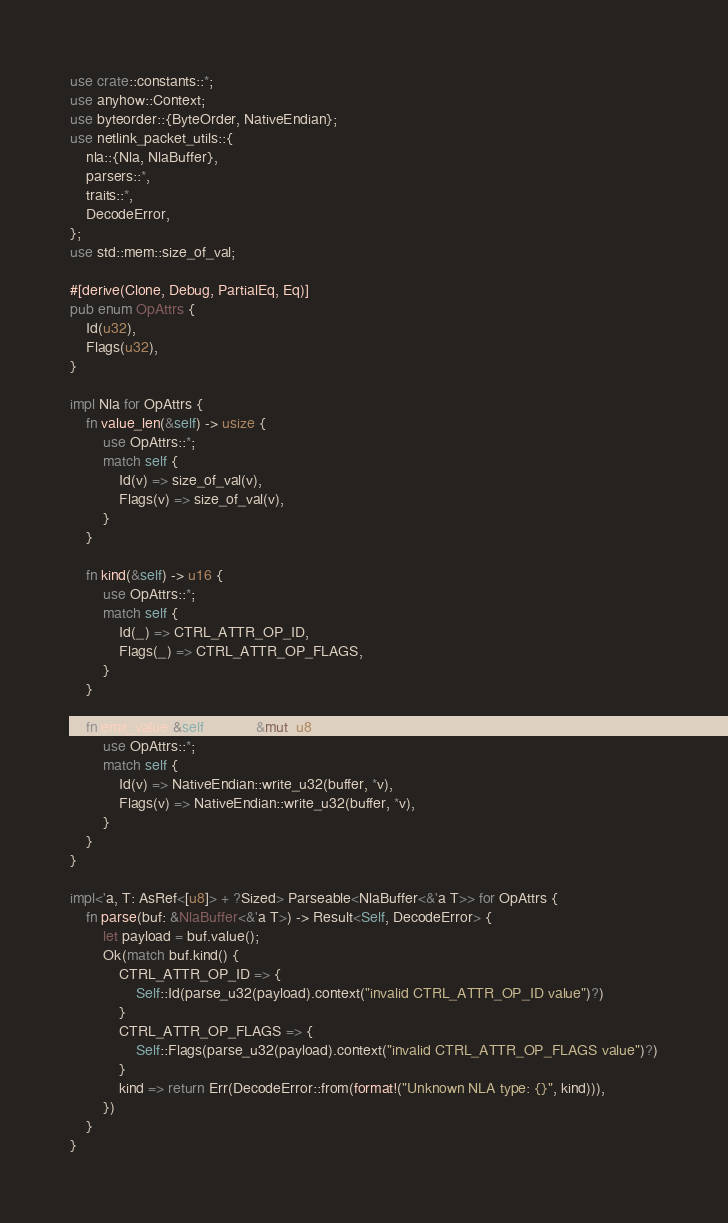Convert code to text. <code><loc_0><loc_0><loc_500><loc_500><_Rust_>use crate::constants::*;
use anyhow::Context;
use byteorder::{ByteOrder, NativeEndian};
use netlink_packet_utils::{
    nla::{Nla, NlaBuffer},
    parsers::*,
    traits::*,
    DecodeError,
};
use std::mem::size_of_val;

#[derive(Clone, Debug, PartialEq, Eq)]
pub enum OpAttrs {
    Id(u32),
    Flags(u32),
}

impl Nla for OpAttrs {
    fn value_len(&self) -> usize {
        use OpAttrs::*;
        match self {
            Id(v) => size_of_val(v),
            Flags(v) => size_of_val(v),
        }
    }

    fn kind(&self) -> u16 {
        use OpAttrs::*;
        match self {
            Id(_) => CTRL_ATTR_OP_ID,
            Flags(_) => CTRL_ATTR_OP_FLAGS,
        }
    }

    fn emit_value(&self, buffer: &mut [u8]) {
        use OpAttrs::*;
        match self {
            Id(v) => NativeEndian::write_u32(buffer, *v),
            Flags(v) => NativeEndian::write_u32(buffer, *v),
        }
    }
}

impl<'a, T: AsRef<[u8]> + ?Sized> Parseable<NlaBuffer<&'a T>> for OpAttrs {
    fn parse(buf: &NlaBuffer<&'a T>) -> Result<Self, DecodeError> {
        let payload = buf.value();
        Ok(match buf.kind() {
            CTRL_ATTR_OP_ID => {
                Self::Id(parse_u32(payload).context("invalid CTRL_ATTR_OP_ID value")?)
            }
            CTRL_ATTR_OP_FLAGS => {
                Self::Flags(parse_u32(payload).context("invalid CTRL_ATTR_OP_FLAGS value")?)
            }
            kind => return Err(DecodeError::from(format!("Unknown NLA type: {}", kind))),
        })
    }
}
</code> 